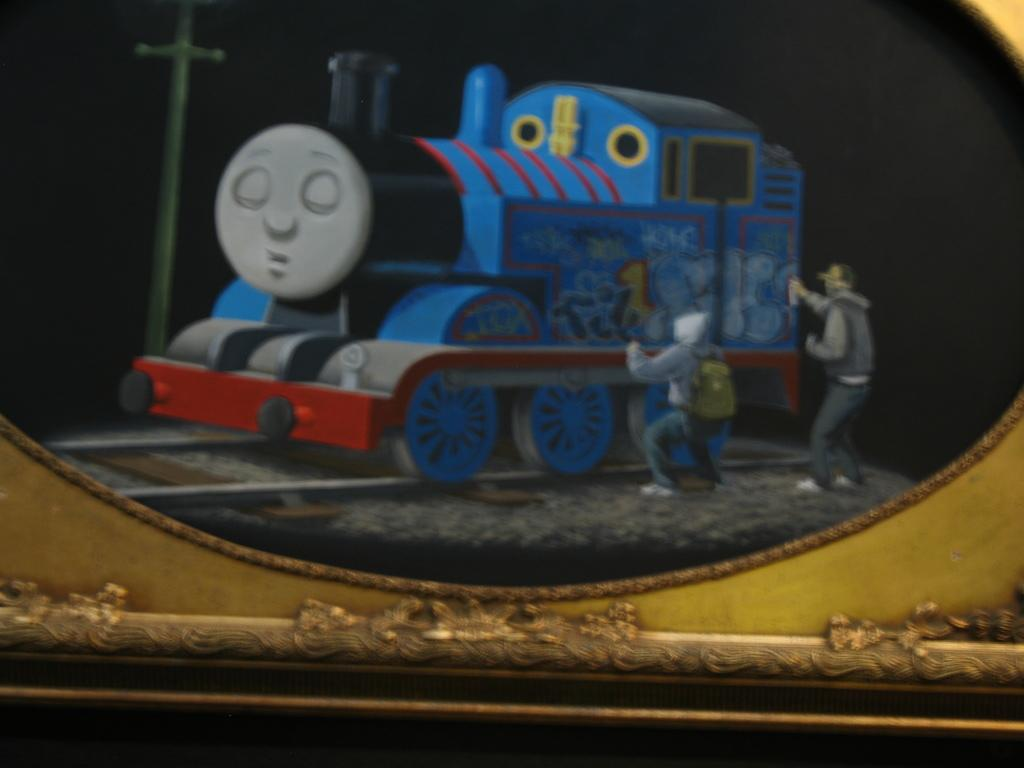What is the main object in the image? There is a train toy in the image. Who is present in the image? There are people in the image. What are the people wearing? The people are wearing clothes, shoes, and caps. What can be seen in the background of the image? The background of the image is dark. What else is present in the image besides the train toy and people? There is a pole in the image. How does the train toy show respect to the people in the image? The train toy is an inanimate object and cannot show respect. --- Facts: 1. There is a car in the image. 2. The car is red. 3. The car has four wheels. 4. There is a road in the image. 5. The road is paved. 6. There are trees in the background of the image. Absurd Topics: dance, laugh, sing Conversation: What is the color of the car in the image? The car is red. How many wheels does the car have? The car has four wheels. What is the surface of the road in the image? The road is paved. What can be seen in the background of the image? There are trees in the background of the image. Reasoning: Let's think step by step in order to produce the conversation. We start by identifying the main subject in the image, which is the car. Then, we describe the car's color and the number of wheels it has. We also mention the road and the trees in the background. Each question is designed to elicit a specific detail about the image that is known from the provided facts. Absurd Question/Answer: Can you hear the car singing a song in the image? Cars do not have the ability to sing songs, so this cannot be heard in the image. 